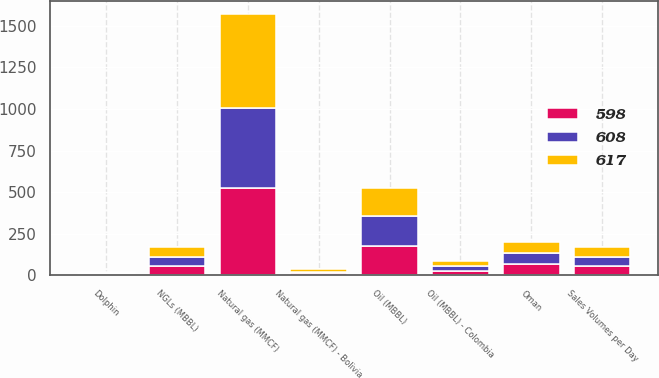Convert chart to OTSL. <chart><loc_0><loc_0><loc_500><loc_500><stacked_bar_chart><ecel><fcel>Sales Volumes per Day<fcel>Oil (MBBL)<fcel>NGLs (MBBL)<fcel>Natural gas (MMCF)<fcel>Oil (MBBL) - Colombia<fcel>Natural gas (MMCF) - Bolivia<fcel>Dolphin<fcel>Oman<nl><fcel>608<fcel>56<fcel>183<fcel>55<fcel>476<fcel>29<fcel>11<fcel>7<fcel>69<nl><fcel>598<fcel>56<fcel>176<fcel>57<fcel>528<fcel>27<fcel>12<fcel>6<fcel>68<nl><fcel>617<fcel>56<fcel>167<fcel>56<fcel>565<fcel>28<fcel>13<fcel>8<fcel>66<nl></chart> 